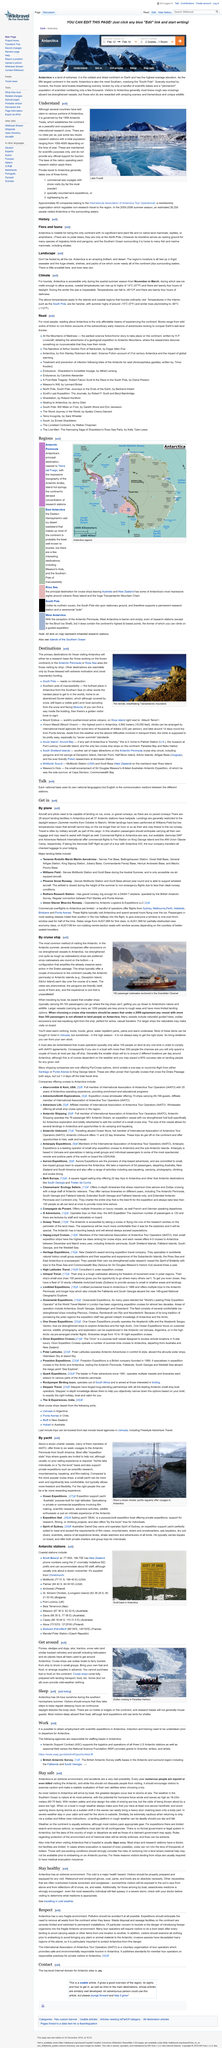Identify some key points in this picture. The population in Antarctica ranges from approximately 1,000 to 4,000 individuals, depending on the time of year. The 1958 Antarctic Treaty, which establishes the continent of Antarctica as a peaceful and cooperative international research zone, aims to promote scientific research and international cooperation while preserving the continent's unique environment. There are three ways in which tourists can travel to Antarctica. 